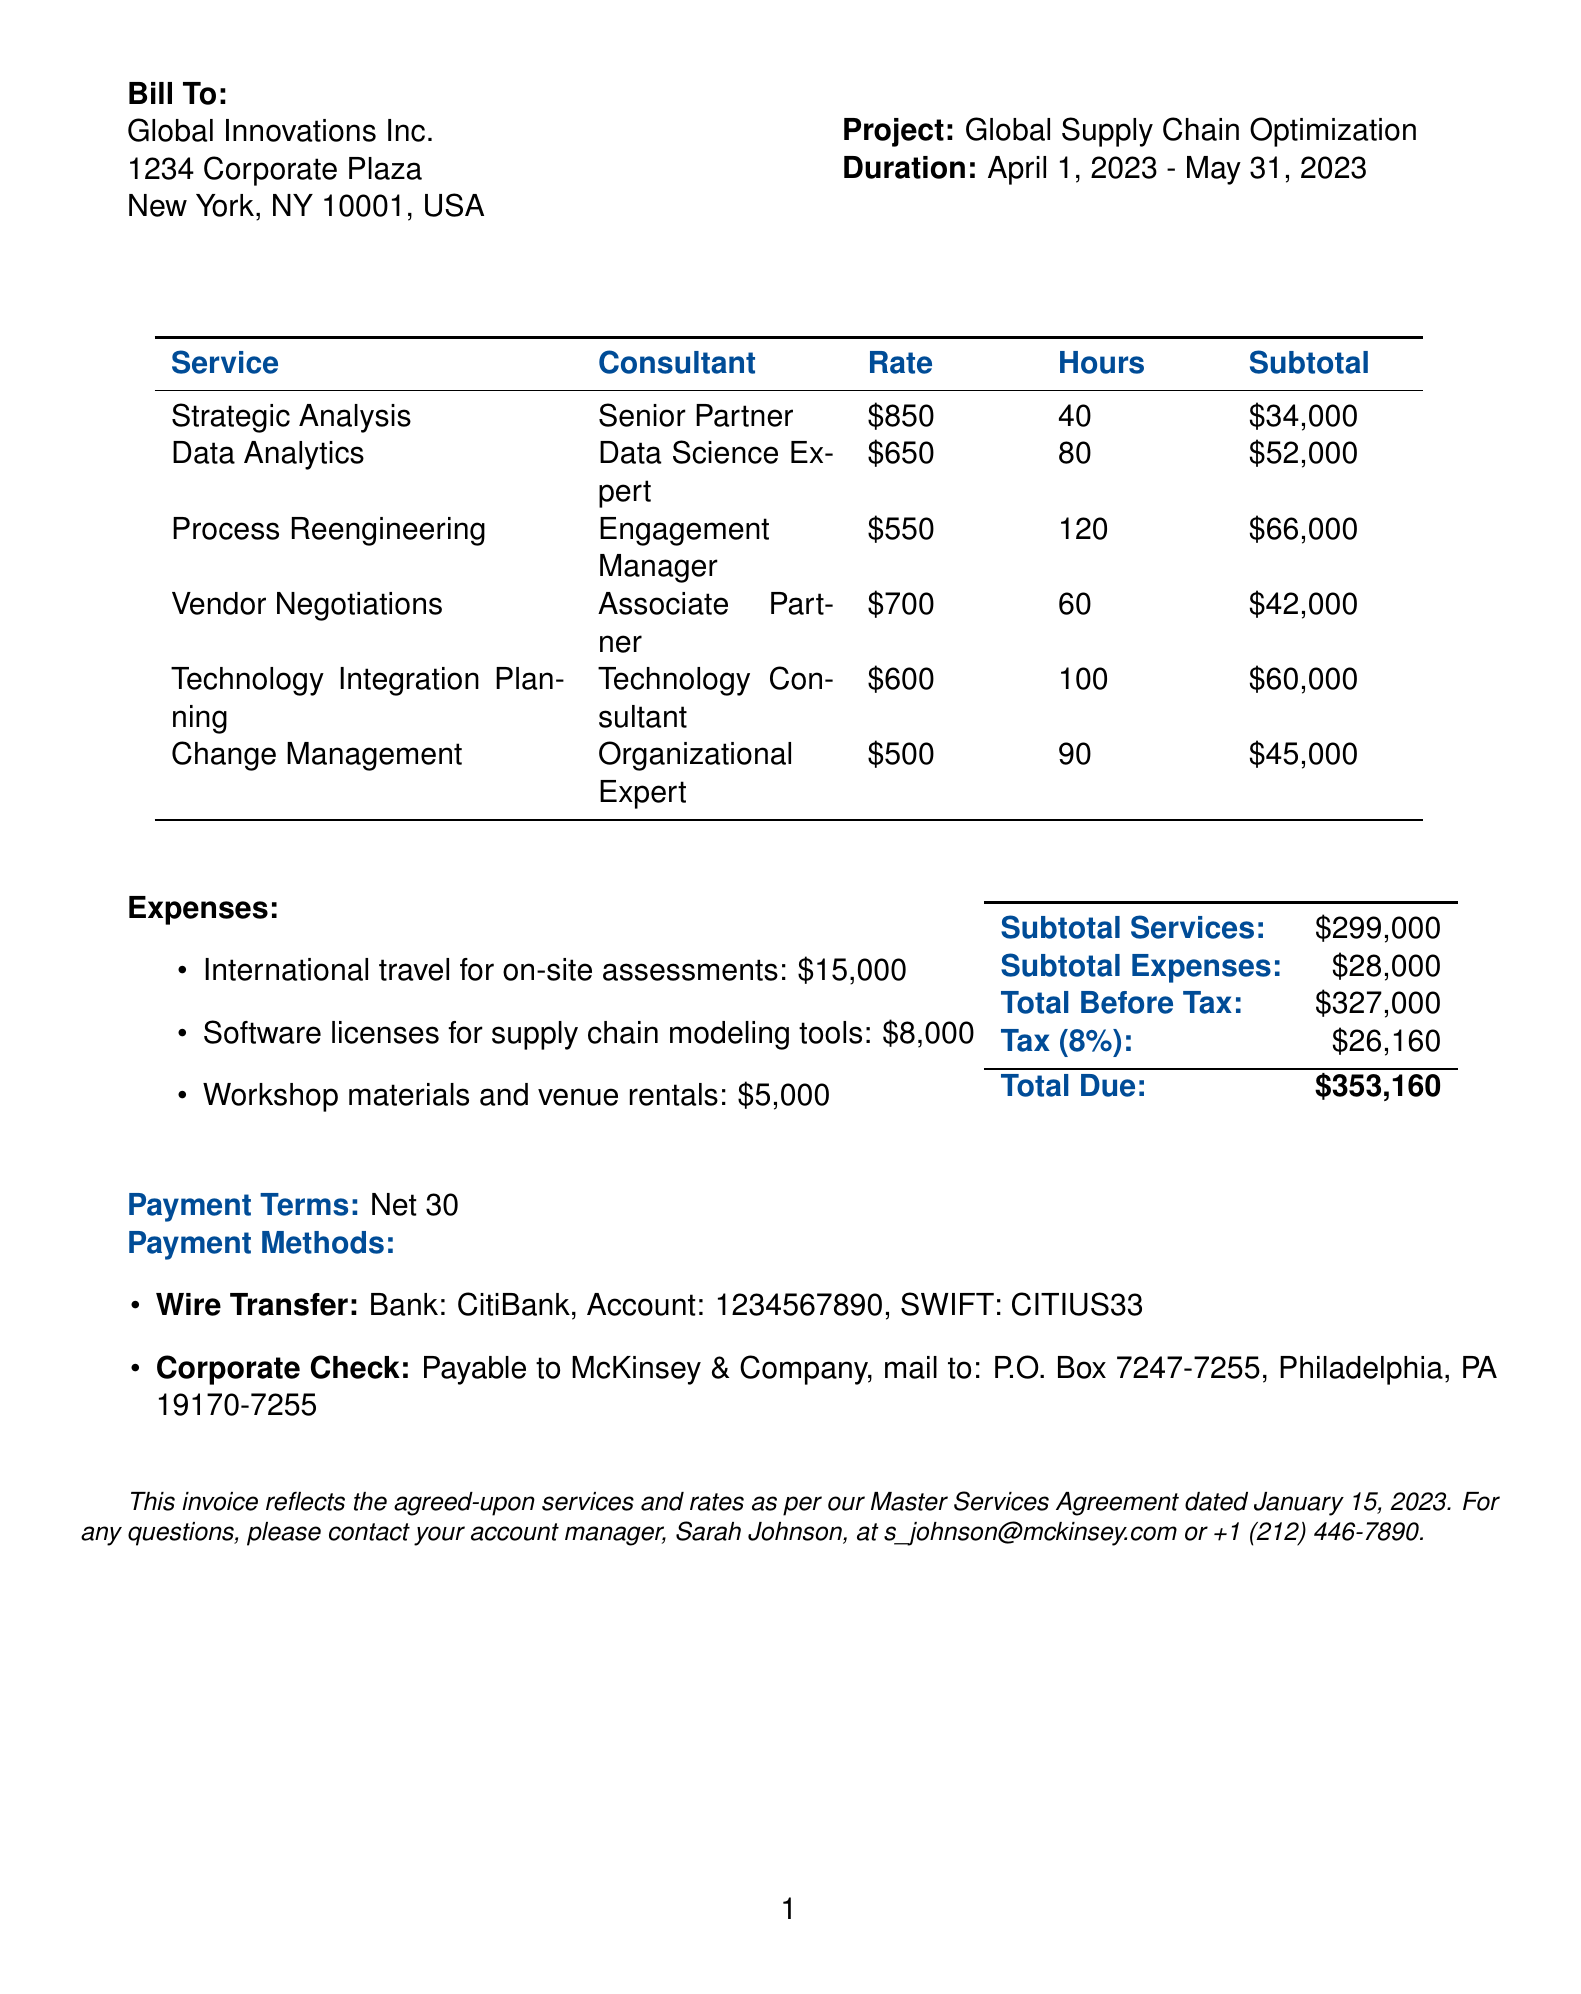what is the invoice number? The invoice number is listed at the top of the document under the invoice details.
Answer: INV-2023-05678 who is the consulting firm? The consulting firm is named at the top of the invoice.
Answer: McKinsey & Company what is the total due amount? The total due amount is calculated from the subtotal services, subtotal expenses, and tax.
Answer: $353,160 how many hours were billed for Process Reengineering? The hours for each service, including Process Reengineering, are detailed in the services breakdown section.
Answer: 120 what is the hourly rate for Data Analytics? The hourly rate can be found in the services breakdown, specifically for the Data Analytics service.
Answer: $650 who is the account manager for this invoice? The account manager's contact information is provided at the bottom of the invoice.
Answer: Sarah Johnson what are the payment terms? Payment terms are stated clearly in the document, summarizing how the payment should be made.
Answer: Net 30 what was the total amount spent on software licenses? The amount for software licenses is listed under expenses on the invoice.
Answer: $8,000 which service has the highest billed hours? The billed hours for each service are detailed in the services breakdown, allowing for comparison.
Answer: Process Reengineering 